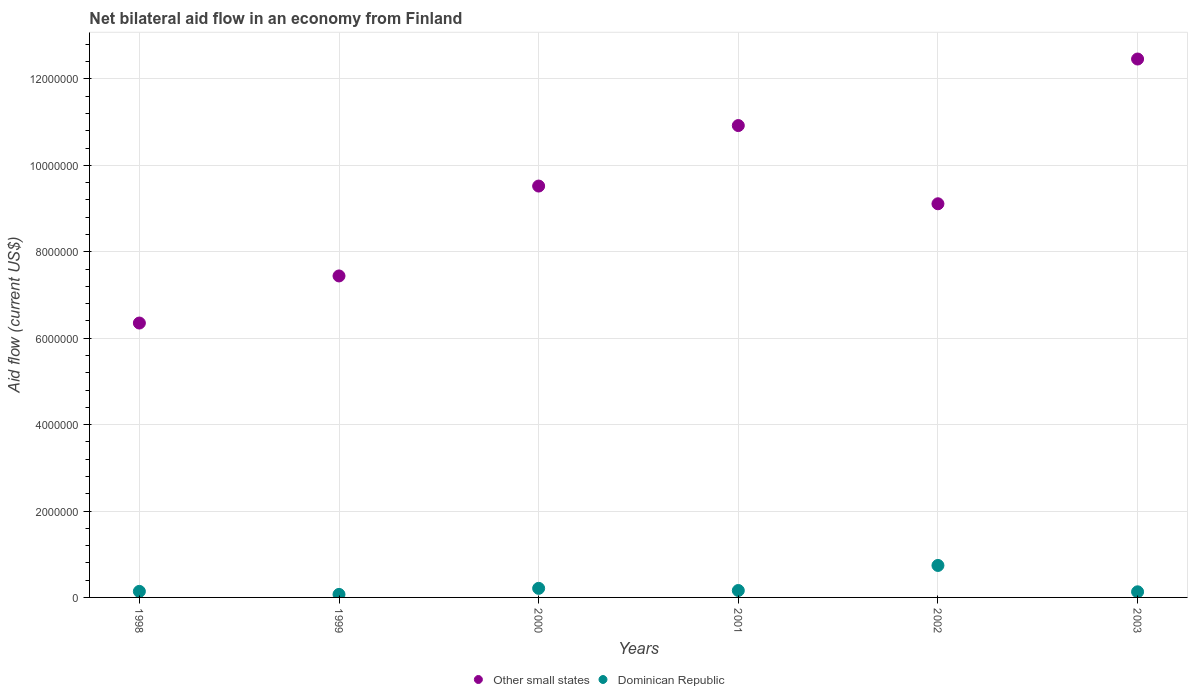Across all years, what is the maximum net bilateral aid flow in Other small states?
Your response must be concise. 1.25e+07. In which year was the net bilateral aid flow in Dominican Republic minimum?
Offer a terse response. 1999. What is the total net bilateral aid flow in Other small states in the graph?
Provide a short and direct response. 5.58e+07. What is the difference between the net bilateral aid flow in Other small states in 2001 and that in 2002?
Your answer should be very brief. 1.81e+06. What is the difference between the net bilateral aid flow in Dominican Republic in 2002 and the net bilateral aid flow in Other small states in 2000?
Your answer should be compact. -8.78e+06. What is the average net bilateral aid flow in Other small states per year?
Your answer should be compact. 9.30e+06. In the year 2000, what is the difference between the net bilateral aid flow in Other small states and net bilateral aid flow in Dominican Republic?
Ensure brevity in your answer.  9.31e+06. What is the ratio of the net bilateral aid flow in Other small states in 1998 to that in 2002?
Offer a terse response. 0.7. Is the difference between the net bilateral aid flow in Other small states in 2000 and 2001 greater than the difference between the net bilateral aid flow in Dominican Republic in 2000 and 2001?
Keep it short and to the point. No. What is the difference between the highest and the second highest net bilateral aid flow in Dominican Republic?
Provide a succinct answer. 5.30e+05. What is the difference between the highest and the lowest net bilateral aid flow in Other small states?
Your answer should be compact. 6.11e+06. Is the sum of the net bilateral aid flow in Dominican Republic in 2002 and 2003 greater than the maximum net bilateral aid flow in Other small states across all years?
Provide a short and direct response. No. Is the net bilateral aid flow in Dominican Republic strictly greater than the net bilateral aid flow in Other small states over the years?
Your response must be concise. No. How many dotlines are there?
Keep it short and to the point. 2. How many years are there in the graph?
Offer a terse response. 6. Does the graph contain grids?
Your answer should be compact. Yes. Where does the legend appear in the graph?
Ensure brevity in your answer.  Bottom center. What is the title of the graph?
Your answer should be compact. Net bilateral aid flow in an economy from Finland. What is the label or title of the X-axis?
Provide a succinct answer. Years. What is the Aid flow (current US$) in Other small states in 1998?
Your answer should be very brief. 6.35e+06. What is the Aid flow (current US$) of Dominican Republic in 1998?
Offer a very short reply. 1.40e+05. What is the Aid flow (current US$) of Other small states in 1999?
Provide a short and direct response. 7.44e+06. What is the Aid flow (current US$) of Other small states in 2000?
Offer a very short reply. 9.52e+06. What is the Aid flow (current US$) in Other small states in 2001?
Offer a very short reply. 1.09e+07. What is the Aid flow (current US$) of Other small states in 2002?
Your answer should be very brief. 9.11e+06. What is the Aid flow (current US$) in Dominican Republic in 2002?
Your answer should be compact. 7.40e+05. What is the Aid flow (current US$) of Other small states in 2003?
Provide a short and direct response. 1.25e+07. What is the Aid flow (current US$) in Dominican Republic in 2003?
Offer a terse response. 1.30e+05. Across all years, what is the maximum Aid flow (current US$) of Other small states?
Give a very brief answer. 1.25e+07. Across all years, what is the maximum Aid flow (current US$) of Dominican Republic?
Your response must be concise. 7.40e+05. Across all years, what is the minimum Aid flow (current US$) in Other small states?
Your answer should be very brief. 6.35e+06. What is the total Aid flow (current US$) in Other small states in the graph?
Make the answer very short. 5.58e+07. What is the total Aid flow (current US$) in Dominican Republic in the graph?
Give a very brief answer. 1.45e+06. What is the difference between the Aid flow (current US$) of Other small states in 1998 and that in 1999?
Give a very brief answer. -1.09e+06. What is the difference between the Aid flow (current US$) in Dominican Republic in 1998 and that in 1999?
Provide a succinct answer. 7.00e+04. What is the difference between the Aid flow (current US$) in Other small states in 1998 and that in 2000?
Your answer should be compact. -3.17e+06. What is the difference between the Aid flow (current US$) in Other small states in 1998 and that in 2001?
Provide a succinct answer. -4.57e+06. What is the difference between the Aid flow (current US$) in Other small states in 1998 and that in 2002?
Your answer should be very brief. -2.76e+06. What is the difference between the Aid flow (current US$) in Dominican Republic in 1998 and that in 2002?
Your answer should be very brief. -6.00e+05. What is the difference between the Aid flow (current US$) of Other small states in 1998 and that in 2003?
Offer a very short reply. -6.11e+06. What is the difference between the Aid flow (current US$) of Other small states in 1999 and that in 2000?
Your response must be concise. -2.08e+06. What is the difference between the Aid flow (current US$) in Dominican Republic in 1999 and that in 2000?
Make the answer very short. -1.40e+05. What is the difference between the Aid flow (current US$) in Other small states in 1999 and that in 2001?
Provide a succinct answer. -3.48e+06. What is the difference between the Aid flow (current US$) of Dominican Republic in 1999 and that in 2001?
Your answer should be compact. -9.00e+04. What is the difference between the Aid flow (current US$) of Other small states in 1999 and that in 2002?
Your answer should be compact. -1.67e+06. What is the difference between the Aid flow (current US$) of Dominican Republic in 1999 and that in 2002?
Your response must be concise. -6.70e+05. What is the difference between the Aid flow (current US$) in Other small states in 1999 and that in 2003?
Your answer should be very brief. -5.02e+06. What is the difference between the Aid flow (current US$) of Other small states in 2000 and that in 2001?
Provide a succinct answer. -1.40e+06. What is the difference between the Aid flow (current US$) of Dominican Republic in 2000 and that in 2001?
Offer a terse response. 5.00e+04. What is the difference between the Aid flow (current US$) in Other small states in 2000 and that in 2002?
Provide a short and direct response. 4.10e+05. What is the difference between the Aid flow (current US$) of Dominican Republic in 2000 and that in 2002?
Your answer should be compact. -5.30e+05. What is the difference between the Aid flow (current US$) in Other small states in 2000 and that in 2003?
Your answer should be compact. -2.94e+06. What is the difference between the Aid flow (current US$) of Dominican Republic in 2000 and that in 2003?
Give a very brief answer. 8.00e+04. What is the difference between the Aid flow (current US$) of Other small states in 2001 and that in 2002?
Make the answer very short. 1.81e+06. What is the difference between the Aid flow (current US$) in Dominican Republic in 2001 and that in 2002?
Make the answer very short. -5.80e+05. What is the difference between the Aid flow (current US$) in Other small states in 2001 and that in 2003?
Make the answer very short. -1.54e+06. What is the difference between the Aid flow (current US$) of Other small states in 2002 and that in 2003?
Offer a very short reply. -3.35e+06. What is the difference between the Aid flow (current US$) in Dominican Republic in 2002 and that in 2003?
Keep it short and to the point. 6.10e+05. What is the difference between the Aid flow (current US$) in Other small states in 1998 and the Aid flow (current US$) in Dominican Republic in 1999?
Provide a short and direct response. 6.28e+06. What is the difference between the Aid flow (current US$) in Other small states in 1998 and the Aid flow (current US$) in Dominican Republic in 2000?
Provide a short and direct response. 6.14e+06. What is the difference between the Aid flow (current US$) of Other small states in 1998 and the Aid flow (current US$) of Dominican Republic in 2001?
Make the answer very short. 6.19e+06. What is the difference between the Aid flow (current US$) in Other small states in 1998 and the Aid flow (current US$) in Dominican Republic in 2002?
Your response must be concise. 5.61e+06. What is the difference between the Aid flow (current US$) of Other small states in 1998 and the Aid flow (current US$) of Dominican Republic in 2003?
Make the answer very short. 6.22e+06. What is the difference between the Aid flow (current US$) of Other small states in 1999 and the Aid flow (current US$) of Dominican Republic in 2000?
Make the answer very short. 7.23e+06. What is the difference between the Aid flow (current US$) of Other small states in 1999 and the Aid flow (current US$) of Dominican Republic in 2001?
Your answer should be very brief. 7.28e+06. What is the difference between the Aid flow (current US$) in Other small states in 1999 and the Aid flow (current US$) in Dominican Republic in 2002?
Your response must be concise. 6.70e+06. What is the difference between the Aid flow (current US$) of Other small states in 1999 and the Aid flow (current US$) of Dominican Republic in 2003?
Provide a short and direct response. 7.31e+06. What is the difference between the Aid flow (current US$) in Other small states in 2000 and the Aid flow (current US$) in Dominican Republic in 2001?
Make the answer very short. 9.36e+06. What is the difference between the Aid flow (current US$) in Other small states in 2000 and the Aid flow (current US$) in Dominican Republic in 2002?
Your response must be concise. 8.78e+06. What is the difference between the Aid flow (current US$) of Other small states in 2000 and the Aid flow (current US$) of Dominican Republic in 2003?
Your response must be concise. 9.39e+06. What is the difference between the Aid flow (current US$) in Other small states in 2001 and the Aid flow (current US$) in Dominican Republic in 2002?
Keep it short and to the point. 1.02e+07. What is the difference between the Aid flow (current US$) of Other small states in 2001 and the Aid flow (current US$) of Dominican Republic in 2003?
Your answer should be compact. 1.08e+07. What is the difference between the Aid flow (current US$) of Other small states in 2002 and the Aid flow (current US$) of Dominican Republic in 2003?
Offer a terse response. 8.98e+06. What is the average Aid flow (current US$) in Other small states per year?
Your response must be concise. 9.30e+06. What is the average Aid flow (current US$) in Dominican Republic per year?
Your response must be concise. 2.42e+05. In the year 1998, what is the difference between the Aid flow (current US$) in Other small states and Aid flow (current US$) in Dominican Republic?
Give a very brief answer. 6.21e+06. In the year 1999, what is the difference between the Aid flow (current US$) in Other small states and Aid flow (current US$) in Dominican Republic?
Offer a terse response. 7.37e+06. In the year 2000, what is the difference between the Aid flow (current US$) of Other small states and Aid flow (current US$) of Dominican Republic?
Provide a succinct answer. 9.31e+06. In the year 2001, what is the difference between the Aid flow (current US$) of Other small states and Aid flow (current US$) of Dominican Republic?
Your answer should be very brief. 1.08e+07. In the year 2002, what is the difference between the Aid flow (current US$) in Other small states and Aid flow (current US$) in Dominican Republic?
Give a very brief answer. 8.37e+06. In the year 2003, what is the difference between the Aid flow (current US$) of Other small states and Aid flow (current US$) of Dominican Republic?
Offer a very short reply. 1.23e+07. What is the ratio of the Aid flow (current US$) of Other small states in 1998 to that in 1999?
Make the answer very short. 0.85. What is the ratio of the Aid flow (current US$) of Other small states in 1998 to that in 2000?
Your response must be concise. 0.67. What is the ratio of the Aid flow (current US$) in Other small states in 1998 to that in 2001?
Offer a terse response. 0.58. What is the ratio of the Aid flow (current US$) of Dominican Republic in 1998 to that in 2001?
Offer a very short reply. 0.88. What is the ratio of the Aid flow (current US$) in Other small states in 1998 to that in 2002?
Ensure brevity in your answer.  0.7. What is the ratio of the Aid flow (current US$) of Dominican Republic in 1998 to that in 2002?
Provide a succinct answer. 0.19. What is the ratio of the Aid flow (current US$) in Other small states in 1998 to that in 2003?
Offer a terse response. 0.51. What is the ratio of the Aid flow (current US$) of Dominican Republic in 1998 to that in 2003?
Make the answer very short. 1.08. What is the ratio of the Aid flow (current US$) of Other small states in 1999 to that in 2000?
Keep it short and to the point. 0.78. What is the ratio of the Aid flow (current US$) of Dominican Republic in 1999 to that in 2000?
Make the answer very short. 0.33. What is the ratio of the Aid flow (current US$) in Other small states in 1999 to that in 2001?
Ensure brevity in your answer.  0.68. What is the ratio of the Aid flow (current US$) of Dominican Republic in 1999 to that in 2001?
Provide a succinct answer. 0.44. What is the ratio of the Aid flow (current US$) of Other small states in 1999 to that in 2002?
Provide a succinct answer. 0.82. What is the ratio of the Aid flow (current US$) in Dominican Republic in 1999 to that in 2002?
Provide a succinct answer. 0.09. What is the ratio of the Aid flow (current US$) of Other small states in 1999 to that in 2003?
Provide a short and direct response. 0.6. What is the ratio of the Aid flow (current US$) in Dominican Republic in 1999 to that in 2003?
Your response must be concise. 0.54. What is the ratio of the Aid flow (current US$) of Other small states in 2000 to that in 2001?
Your response must be concise. 0.87. What is the ratio of the Aid flow (current US$) in Dominican Republic in 2000 to that in 2001?
Your response must be concise. 1.31. What is the ratio of the Aid flow (current US$) of Other small states in 2000 to that in 2002?
Keep it short and to the point. 1.04. What is the ratio of the Aid flow (current US$) in Dominican Republic in 2000 to that in 2002?
Keep it short and to the point. 0.28. What is the ratio of the Aid flow (current US$) in Other small states in 2000 to that in 2003?
Keep it short and to the point. 0.76. What is the ratio of the Aid flow (current US$) in Dominican Republic in 2000 to that in 2003?
Your response must be concise. 1.62. What is the ratio of the Aid flow (current US$) in Other small states in 2001 to that in 2002?
Ensure brevity in your answer.  1.2. What is the ratio of the Aid flow (current US$) of Dominican Republic in 2001 to that in 2002?
Your response must be concise. 0.22. What is the ratio of the Aid flow (current US$) of Other small states in 2001 to that in 2003?
Provide a succinct answer. 0.88. What is the ratio of the Aid flow (current US$) of Dominican Republic in 2001 to that in 2003?
Ensure brevity in your answer.  1.23. What is the ratio of the Aid flow (current US$) in Other small states in 2002 to that in 2003?
Offer a very short reply. 0.73. What is the ratio of the Aid flow (current US$) in Dominican Republic in 2002 to that in 2003?
Provide a short and direct response. 5.69. What is the difference between the highest and the second highest Aid flow (current US$) in Other small states?
Ensure brevity in your answer.  1.54e+06. What is the difference between the highest and the second highest Aid flow (current US$) of Dominican Republic?
Keep it short and to the point. 5.30e+05. What is the difference between the highest and the lowest Aid flow (current US$) in Other small states?
Make the answer very short. 6.11e+06. What is the difference between the highest and the lowest Aid flow (current US$) of Dominican Republic?
Keep it short and to the point. 6.70e+05. 